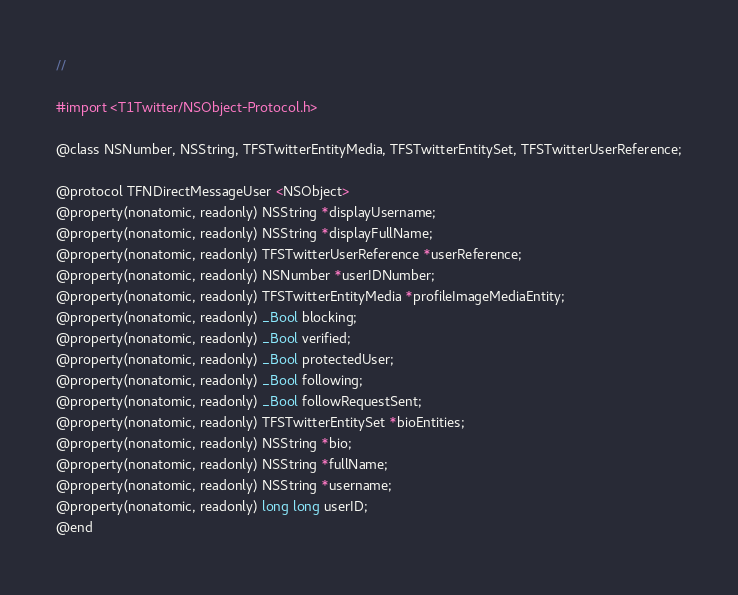<code> <loc_0><loc_0><loc_500><loc_500><_C_>//

#import <T1Twitter/NSObject-Protocol.h>

@class NSNumber, NSString, TFSTwitterEntityMedia, TFSTwitterEntitySet, TFSTwitterUserReference;

@protocol TFNDirectMessageUser <NSObject>
@property(nonatomic, readonly) NSString *displayUsername;
@property(nonatomic, readonly) NSString *displayFullName;
@property(nonatomic, readonly) TFSTwitterUserReference *userReference;
@property(nonatomic, readonly) NSNumber *userIDNumber;
@property(nonatomic, readonly) TFSTwitterEntityMedia *profileImageMediaEntity;
@property(nonatomic, readonly) _Bool blocking;
@property(nonatomic, readonly) _Bool verified;
@property(nonatomic, readonly) _Bool protectedUser;
@property(nonatomic, readonly) _Bool following;
@property(nonatomic, readonly) _Bool followRequestSent;
@property(nonatomic, readonly) TFSTwitterEntitySet *bioEntities;
@property(nonatomic, readonly) NSString *bio;
@property(nonatomic, readonly) NSString *fullName;
@property(nonatomic, readonly) NSString *username;
@property(nonatomic, readonly) long long userID;
@end

</code> 